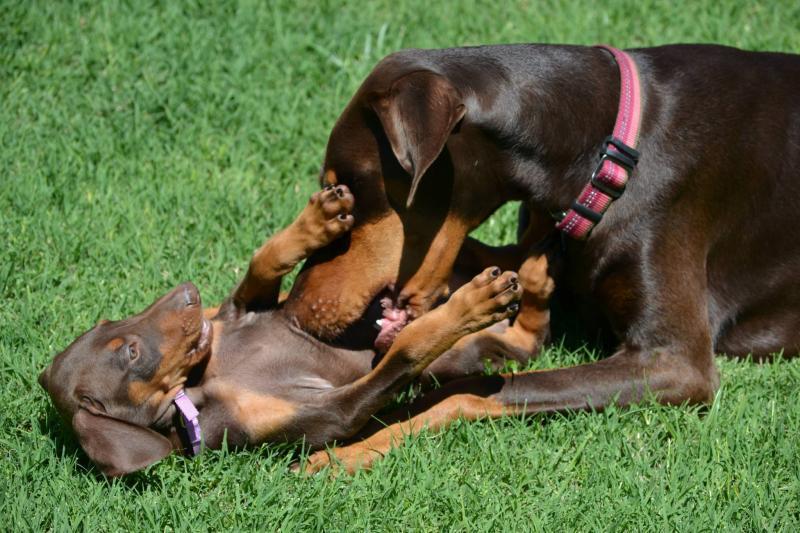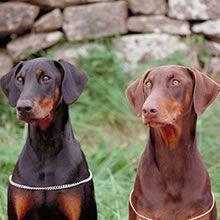The first image is the image on the left, the second image is the image on the right. Assess this claim about the two images: "The right image features two side-by-side forward-facing floppy-eared doberman with collar-like things around their shoulders.". Correct or not? Answer yes or no. Yes. 